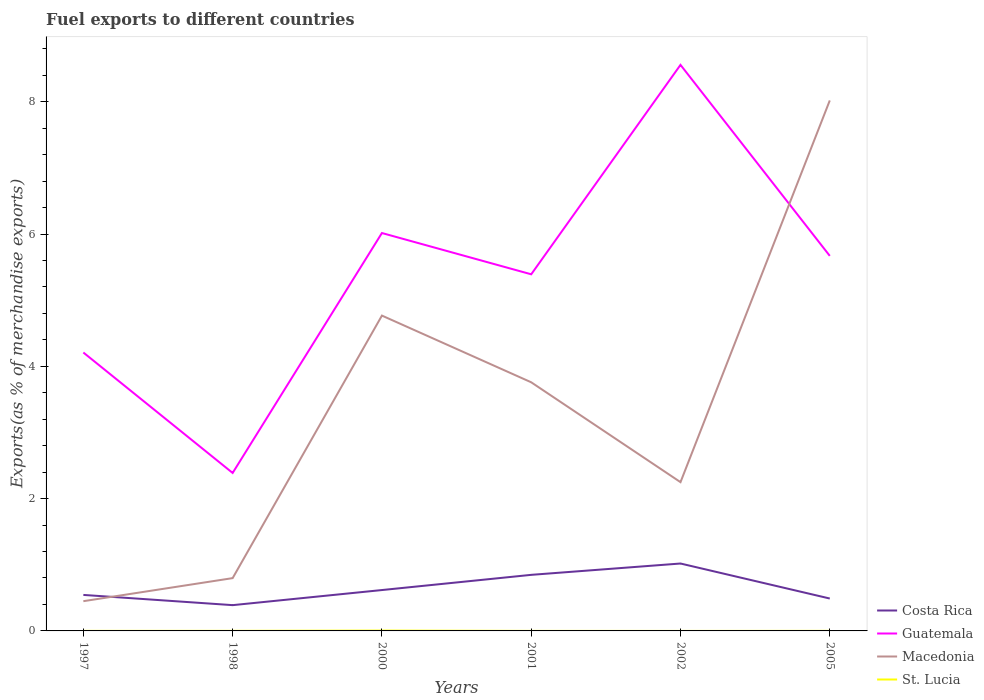Does the line corresponding to Costa Rica intersect with the line corresponding to Macedonia?
Give a very brief answer. Yes. Across all years, what is the maximum percentage of exports to different countries in Costa Rica?
Make the answer very short. 0.39. In which year was the percentage of exports to different countries in Macedonia maximum?
Your answer should be compact. 1997. What is the total percentage of exports to different countries in Guatemala in the graph?
Provide a succinct answer. -1.18. What is the difference between the highest and the second highest percentage of exports to different countries in Guatemala?
Ensure brevity in your answer.  6.17. Are the values on the major ticks of Y-axis written in scientific E-notation?
Ensure brevity in your answer.  No. Does the graph contain any zero values?
Your response must be concise. No. What is the title of the graph?
Your answer should be very brief. Fuel exports to different countries. Does "Indonesia" appear as one of the legend labels in the graph?
Give a very brief answer. No. What is the label or title of the X-axis?
Give a very brief answer. Years. What is the label or title of the Y-axis?
Your answer should be compact. Exports(as % of merchandise exports). What is the Exports(as % of merchandise exports) in Costa Rica in 1997?
Provide a succinct answer. 0.54. What is the Exports(as % of merchandise exports) in Guatemala in 1997?
Ensure brevity in your answer.  4.21. What is the Exports(as % of merchandise exports) of Macedonia in 1997?
Your answer should be compact. 0.45. What is the Exports(as % of merchandise exports) in St. Lucia in 1997?
Offer a very short reply. 0. What is the Exports(as % of merchandise exports) of Costa Rica in 1998?
Keep it short and to the point. 0.39. What is the Exports(as % of merchandise exports) in Guatemala in 1998?
Provide a short and direct response. 2.39. What is the Exports(as % of merchandise exports) in Macedonia in 1998?
Make the answer very short. 0.8. What is the Exports(as % of merchandise exports) of St. Lucia in 1998?
Offer a terse response. 0. What is the Exports(as % of merchandise exports) of Costa Rica in 2000?
Keep it short and to the point. 0.62. What is the Exports(as % of merchandise exports) in Guatemala in 2000?
Keep it short and to the point. 6.01. What is the Exports(as % of merchandise exports) in Macedonia in 2000?
Your answer should be compact. 4.77. What is the Exports(as % of merchandise exports) of St. Lucia in 2000?
Your response must be concise. 0.01. What is the Exports(as % of merchandise exports) of Costa Rica in 2001?
Your answer should be very brief. 0.85. What is the Exports(as % of merchandise exports) in Guatemala in 2001?
Provide a succinct answer. 5.39. What is the Exports(as % of merchandise exports) in Macedonia in 2001?
Your answer should be compact. 3.76. What is the Exports(as % of merchandise exports) of St. Lucia in 2001?
Your answer should be very brief. 0. What is the Exports(as % of merchandise exports) of Costa Rica in 2002?
Ensure brevity in your answer.  1.02. What is the Exports(as % of merchandise exports) of Guatemala in 2002?
Make the answer very short. 8.56. What is the Exports(as % of merchandise exports) of Macedonia in 2002?
Your answer should be very brief. 2.25. What is the Exports(as % of merchandise exports) of St. Lucia in 2002?
Your answer should be very brief. 4.657797227082891e-6. What is the Exports(as % of merchandise exports) of Costa Rica in 2005?
Make the answer very short. 0.49. What is the Exports(as % of merchandise exports) of Guatemala in 2005?
Your answer should be compact. 5.67. What is the Exports(as % of merchandise exports) in Macedonia in 2005?
Offer a terse response. 8.02. What is the Exports(as % of merchandise exports) of St. Lucia in 2005?
Offer a terse response. 0. Across all years, what is the maximum Exports(as % of merchandise exports) of Costa Rica?
Provide a short and direct response. 1.02. Across all years, what is the maximum Exports(as % of merchandise exports) of Guatemala?
Provide a short and direct response. 8.56. Across all years, what is the maximum Exports(as % of merchandise exports) in Macedonia?
Offer a very short reply. 8.02. Across all years, what is the maximum Exports(as % of merchandise exports) of St. Lucia?
Provide a short and direct response. 0.01. Across all years, what is the minimum Exports(as % of merchandise exports) in Costa Rica?
Your response must be concise. 0.39. Across all years, what is the minimum Exports(as % of merchandise exports) of Guatemala?
Provide a succinct answer. 2.39. Across all years, what is the minimum Exports(as % of merchandise exports) in Macedonia?
Give a very brief answer. 0.45. Across all years, what is the minimum Exports(as % of merchandise exports) of St. Lucia?
Your answer should be very brief. 4.657797227082891e-6. What is the total Exports(as % of merchandise exports) in Costa Rica in the graph?
Keep it short and to the point. 3.91. What is the total Exports(as % of merchandise exports) in Guatemala in the graph?
Your response must be concise. 32.23. What is the total Exports(as % of merchandise exports) in Macedonia in the graph?
Make the answer very short. 20.04. What is the total Exports(as % of merchandise exports) in St. Lucia in the graph?
Ensure brevity in your answer.  0.01. What is the difference between the Exports(as % of merchandise exports) in Costa Rica in 1997 and that in 1998?
Ensure brevity in your answer.  0.15. What is the difference between the Exports(as % of merchandise exports) of Guatemala in 1997 and that in 1998?
Give a very brief answer. 1.82. What is the difference between the Exports(as % of merchandise exports) in Macedonia in 1997 and that in 1998?
Make the answer very short. -0.35. What is the difference between the Exports(as % of merchandise exports) in St. Lucia in 1997 and that in 1998?
Offer a terse response. -0. What is the difference between the Exports(as % of merchandise exports) in Costa Rica in 1997 and that in 2000?
Your response must be concise. -0.07. What is the difference between the Exports(as % of merchandise exports) of Guatemala in 1997 and that in 2000?
Offer a terse response. -1.81. What is the difference between the Exports(as % of merchandise exports) in Macedonia in 1997 and that in 2000?
Your answer should be compact. -4.32. What is the difference between the Exports(as % of merchandise exports) in St. Lucia in 1997 and that in 2000?
Your answer should be very brief. -0. What is the difference between the Exports(as % of merchandise exports) in Costa Rica in 1997 and that in 2001?
Your response must be concise. -0.3. What is the difference between the Exports(as % of merchandise exports) in Guatemala in 1997 and that in 2001?
Give a very brief answer. -1.18. What is the difference between the Exports(as % of merchandise exports) of Macedonia in 1997 and that in 2001?
Your response must be concise. -3.31. What is the difference between the Exports(as % of merchandise exports) in Costa Rica in 1997 and that in 2002?
Offer a very short reply. -0.47. What is the difference between the Exports(as % of merchandise exports) of Guatemala in 1997 and that in 2002?
Give a very brief answer. -4.35. What is the difference between the Exports(as % of merchandise exports) of Macedonia in 1997 and that in 2002?
Provide a short and direct response. -1.8. What is the difference between the Exports(as % of merchandise exports) of St. Lucia in 1997 and that in 2002?
Your response must be concise. 0. What is the difference between the Exports(as % of merchandise exports) of Costa Rica in 1997 and that in 2005?
Provide a short and direct response. 0.05. What is the difference between the Exports(as % of merchandise exports) in Guatemala in 1997 and that in 2005?
Offer a very short reply. -1.46. What is the difference between the Exports(as % of merchandise exports) in Macedonia in 1997 and that in 2005?
Make the answer very short. -7.57. What is the difference between the Exports(as % of merchandise exports) of St. Lucia in 1997 and that in 2005?
Your answer should be compact. -0. What is the difference between the Exports(as % of merchandise exports) in Costa Rica in 1998 and that in 2000?
Your response must be concise. -0.23. What is the difference between the Exports(as % of merchandise exports) in Guatemala in 1998 and that in 2000?
Ensure brevity in your answer.  -3.63. What is the difference between the Exports(as % of merchandise exports) in Macedonia in 1998 and that in 2000?
Make the answer very short. -3.97. What is the difference between the Exports(as % of merchandise exports) in St. Lucia in 1998 and that in 2000?
Ensure brevity in your answer.  -0. What is the difference between the Exports(as % of merchandise exports) in Costa Rica in 1998 and that in 2001?
Give a very brief answer. -0.46. What is the difference between the Exports(as % of merchandise exports) in Guatemala in 1998 and that in 2001?
Provide a short and direct response. -3. What is the difference between the Exports(as % of merchandise exports) of Macedonia in 1998 and that in 2001?
Provide a short and direct response. -2.96. What is the difference between the Exports(as % of merchandise exports) of St. Lucia in 1998 and that in 2001?
Make the answer very short. 0. What is the difference between the Exports(as % of merchandise exports) in Costa Rica in 1998 and that in 2002?
Provide a succinct answer. -0.63. What is the difference between the Exports(as % of merchandise exports) of Guatemala in 1998 and that in 2002?
Keep it short and to the point. -6.17. What is the difference between the Exports(as % of merchandise exports) in Macedonia in 1998 and that in 2002?
Provide a short and direct response. -1.45. What is the difference between the Exports(as % of merchandise exports) in St. Lucia in 1998 and that in 2002?
Provide a succinct answer. 0. What is the difference between the Exports(as % of merchandise exports) of Costa Rica in 1998 and that in 2005?
Provide a succinct answer. -0.1. What is the difference between the Exports(as % of merchandise exports) of Guatemala in 1998 and that in 2005?
Your response must be concise. -3.28. What is the difference between the Exports(as % of merchandise exports) in Macedonia in 1998 and that in 2005?
Make the answer very short. -7.22. What is the difference between the Exports(as % of merchandise exports) of St. Lucia in 1998 and that in 2005?
Your response must be concise. 0. What is the difference between the Exports(as % of merchandise exports) in Costa Rica in 2000 and that in 2001?
Make the answer very short. -0.23. What is the difference between the Exports(as % of merchandise exports) of Guatemala in 2000 and that in 2001?
Your answer should be very brief. 0.62. What is the difference between the Exports(as % of merchandise exports) in Macedonia in 2000 and that in 2001?
Offer a terse response. 1.01. What is the difference between the Exports(as % of merchandise exports) of St. Lucia in 2000 and that in 2001?
Keep it short and to the point. 0. What is the difference between the Exports(as % of merchandise exports) of Costa Rica in 2000 and that in 2002?
Keep it short and to the point. -0.4. What is the difference between the Exports(as % of merchandise exports) in Guatemala in 2000 and that in 2002?
Your response must be concise. -2.54. What is the difference between the Exports(as % of merchandise exports) in Macedonia in 2000 and that in 2002?
Your answer should be compact. 2.52. What is the difference between the Exports(as % of merchandise exports) of St. Lucia in 2000 and that in 2002?
Provide a succinct answer. 0.01. What is the difference between the Exports(as % of merchandise exports) of Costa Rica in 2000 and that in 2005?
Keep it short and to the point. 0.13. What is the difference between the Exports(as % of merchandise exports) in Guatemala in 2000 and that in 2005?
Offer a very short reply. 0.35. What is the difference between the Exports(as % of merchandise exports) of Macedonia in 2000 and that in 2005?
Provide a short and direct response. -3.25. What is the difference between the Exports(as % of merchandise exports) of St. Lucia in 2000 and that in 2005?
Ensure brevity in your answer.  0. What is the difference between the Exports(as % of merchandise exports) in Costa Rica in 2001 and that in 2002?
Your response must be concise. -0.17. What is the difference between the Exports(as % of merchandise exports) in Guatemala in 2001 and that in 2002?
Offer a terse response. -3.17. What is the difference between the Exports(as % of merchandise exports) of Macedonia in 2001 and that in 2002?
Give a very brief answer. 1.51. What is the difference between the Exports(as % of merchandise exports) of St. Lucia in 2001 and that in 2002?
Your response must be concise. 0. What is the difference between the Exports(as % of merchandise exports) in Costa Rica in 2001 and that in 2005?
Offer a terse response. 0.36. What is the difference between the Exports(as % of merchandise exports) of Guatemala in 2001 and that in 2005?
Your response must be concise. -0.28. What is the difference between the Exports(as % of merchandise exports) in Macedonia in 2001 and that in 2005?
Offer a terse response. -4.26. What is the difference between the Exports(as % of merchandise exports) of St. Lucia in 2001 and that in 2005?
Give a very brief answer. -0. What is the difference between the Exports(as % of merchandise exports) of Costa Rica in 2002 and that in 2005?
Offer a terse response. 0.53. What is the difference between the Exports(as % of merchandise exports) of Guatemala in 2002 and that in 2005?
Your answer should be compact. 2.89. What is the difference between the Exports(as % of merchandise exports) in Macedonia in 2002 and that in 2005?
Keep it short and to the point. -5.77. What is the difference between the Exports(as % of merchandise exports) in St. Lucia in 2002 and that in 2005?
Ensure brevity in your answer.  -0. What is the difference between the Exports(as % of merchandise exports) of Costa Rica in 1997 and the Exports(as % of merchandise exports) of Guatemala in 1998?
Your answer should be very brief. -1.84. What is the difference between the Exports(as % of merchandise exports) of Costa Rica in 1997 and the Exports(as % of merchandise exports) of Macedonia in 1998?
Your response must be concise. -0.25. What is the difference between the Exports(as % of merchandise exports) in Costa Rica in 1997 and the Exports(as % of merchandise exports) in St. Lucia in 1998?
Provide a succinct answer. 0.54. What is the difference between the Exports(as % of merchandise exports) in Guatemala in 1997 and the Exports(as % of merchandise exports) in Macedonia in 1998?
Give a very brief answer. 3.41. What is the difference between the Exports(as % of merchandise exports) in Guatemala in 1997 and the Exports(as % of merchandise exports) in St. Lucia in 1998?
Provide a succinct answer. 4.21. What is the difference between the Exports(as % of merchandise exports) of Macedonia in 1997 and the Exports(as % of merchandise exports) of St. Lucia in 1998?
Your answer should be compact. 0.45. What is the difference between the Exports(as % of merchandise exports) of Costa Rica in 1997 and the Exports(as % of merchandise exports) of Guatemala in 2000?
Your answer should be compact. -5.47. What is the difference between the Exports(as % of merchandise exports) of Costa Rica in 1997 and the Exports(as % of merchandise exports) of Macedonia in 2000?
Provide a succinct answer. -4.22. What is the difference between the Exports(as % of merchandise exports) of Costa Rica in 1997 and the Exports(as % of merchandise exports) of St. Lucia in 2000?
Make the answer very short. 0.54. What is the difference between the Exports(as % of merchandise exports) in Guatemala in 1997 and the Exports(as % of merchandise exports) in Macedonia in 2000?
Provide a succinct answer. -0.56. What is the difference between the Exports(as % of merchandise exports) in Guatemala in 1997 and the Exports(as % of merchandise exports) in St. Lucia in 2000?
Give a very brief answer. 4.2. What is the difference between the Exports(as % of merchandise exports) of Macedonia in 1997 and the Exports(as % of merchandise exports) of St. Lucia in 2000?
Give a very brief answer. 0.44. What is the difference between the Exports(as % of merchandise exports) of Costa Rica in 1997 and the Exports(as % of merchandise exports) of Guatemala in 2001?
Provide a short and direct response. -4.85. What is the difference between the Exports(as % of merchandise exports) in Costa Rica in 1997 and the Exports(as % of merchandise exports) in Macedonia in 2001?
Make the answer very short. -3.21. What is the difference between the Exports(as % of merchandise exports) of Costa Rica in 1997 and the Exports(as % of merchandise exports) of St. Lucia in 2001?
Ensure brevity in your answer.  0.54. What is the difference between the Exports(as % of merchandise exports) of Guatemala in 1997 and the Exports(as % of merchandise exports) of Macedonia in 2001?
Offer a very short reply. 0.45. What is the difference between the Exports(as % of merchandise exports) of Guatemala in 1997 and the Exports(as % of merchandise exports) of St. Lucia in 2001?
Your answer should be compact. 4.21. What is the difference between the Exports(as % of merchandise exports) in Macedonia in 1997 and the Exports(as % of merchandise exports) in St. Lucia in 2001?
Offer a very short reply. 0.45. What is the difference between the Exports(as % of merchandise exports) in Costa Rica in 1997 and the Exports(as % of merchandise exports) in Guatemala in 2002?
Your answer should be very brief. -8.01. What is the difference between the Exports(as % of merchandise exports) in Costa Rica in 1997 and the Exports(as % of merchandise exports) in Macedonia in 2002?
Your answer should be very brief. -1.7. What is the difference between the Exports(as % of merchandise exports) of Costa Rica in 1997 and the Exports(as % of merchandise exports) of St. Lucia in 2002?
Provide a short and direct response. 0.54. What is the difference between the Exports(as % of merchandise exports) in Guatemala in 1997 and the Exports(as % of merchandise exports) in Macedonia in 2002?
Provide a short and direct response. 1.96. What is the difference between the Exports(as % of merchandise exports) of Guatemala in 1997 and the Exports(as % of merchandise exports) of St. Lucia in 2002?
Your answer should be compact. 4.21. What is the difference between the Exports(as % of merchandise exports) in Macedonia in 1997 and the Exports(as % of merchandise exports) in St. Lucia in 2002?
Provide a succinct answer. 0.45. What is the difference between the Exports(as % of merchandise exports) in Costa Rica in 1997 and the Exports(as % of merchandise exports) in Guatemala in 2005?
Offer a very short reply. -5.12. What is the difference between the Exports(as % of merchandise exports) of Costa Rica in 1997 and the Exports(as % of merchandise exports) of Macedonia in 2005?
Provide a succinct answer. -7.47. What is the difference between the Exports(as % of merchandise exports) in Costa Rica in 1997 and the Exports(as % of merchandise exports) in St. Lucia in 2005?
Provide a succinct answer. 0.54. What is the difference between the Exports(as % of merchandise exports) in Guatemala in 1997 and the Exports(as % of merchandise exports) in Macedonia in 2005?
Make the answer very short. -3.81. What is the difference between the Exports(as % of merchandise exports) in Guatemala in 1997 and the Exports(as % of merchandise exports) in St. Lucia in 2005?
Give a very brief answer. 4.21. What is the difference between the Exports(as % of merchandise exports) in Macedonia in 1997 and the Exports(as % of merchandise exports) in St. Lucia in 2005?
Keep it short and to the point. 0.45. What is the difference between the Exports(as % of merchandise exports) in Costa Rica in 1998 and the Exports(as % of merchandise exports) in Guatemala in 2000?
Your response must be concise. -5.63. What is the difference between the Exports(as % of merchandise exports) of Costa Rica in 1998 and the Exports(as % of merchandise exports) of Macedonia in 2000?
Your response must be concise. -4.38. What is the difference between the Exports(as % of merchandise exports) in Costa Rica in 1998 and the Exports(as % of merchandise exports) in St. Lucia in 2000?
Give a very brief answer. 0.38. What is the difference between the Exports(as % of merchandise exports) in Guatemala in 1998 and the Exports(as % of merchandise exports) in Macedonia in 2000?
Your answer should be compact. -2.38. What is the difference between the Exports(as % of merchandise exports) in Guatemala in 1998 and the Exports(as % of merchandise exports) in St. Lucia in 2000?
Keep it short and to the point. 2.38. What is the difference between the Exports(as % of merchandise exports) of Macedonia in 1998 and the Exports(as % of merchandise exports) of St. Lucia in 2000?
Provide a short and direct response. 0.79. What is the difference between the Exports(as % of merchandise exports) in Costa Rica in 1998 and the Exports(as % of merchandise exports) in Guatemala in 2001?
Give a very brief answer. -5. What is the difference between the Exports(as % of merchandise exports) of Costa Rica in 1998 and the Exports(as % of merchandise exports) of Macedonia in 2001?
Make the answer very short. -3.37. What is the difference between the Exports(as % of merchandise exports) of Costa Rica in 1998 and the Exports(as % of merchandise exports) of St. Lucia in 2001?
Your answer should be very brief. 0.39. What is the difference between the Exports(as % of merchandise exports) in Guatemala in 1998 and the Exports(as % of merchandise exports) in Macedonia in 2001?
Your answer should be very brief. -1.37. What is the difference between the Exports(as % of merchandise exports) in Guatemala in 1998 and the Exports(as % of merchandise exports) in St. Lucia in 2001?
Your response must be concise. 2.39. What is the difference between the Exports(as % of merchandise exports) in Macedonia in 1998 and the Exports(as % of merchandise exports) in St. Lucia in 2001?
Provide a short and direct response. 0.8. What is the difference between the Exports(as % of merchandise exports) of Costa Rica in 1998 and the Exports(as % of merchandise exports) of Guatemala in 2002?
Offer a terse response. -8.17. What is the difference between the Exports(as % of merchandise exports) in Costa Rica in 1998 and the Exports(as % of merchandise exports) in Macedonia in 2002?
Give a very brief answer. -1.86. What is the difference between the Exports(as % of merchandise exports) in Costa Rica in 1998 and the Exports(as % of merchandise exports) in St. Lucia in 2002?
Give a very brief answer. 0.39. What is the difference between the Exports(as % of merchandise exports) of Guatemala in 1998 and the Exports(as % of merchandise exports) of Macedonia in 2002?
Offer a terse response. 0.14. What is the difference between the Exports(as % of merchandise exports) of Guatemala in 1998 and the Exports(as % of merchandise exports) of St. Lucia in 2002?
Your answer should be very brief. 2.39. What is the difference between the Exports(as % of merchandise exports) in Macedonia in 1998 and the Exports(as % of merchandise exports) in St. Lucia in 2002?
Provide a succinct answer. 0.8. What is the difference between the Exports(as % of merchandise exports) of Costa Rica in 1998 and the Exports(as % of merchandise exports) of Guatemala in 2005?
Offer a terse response. -5.28. What is the difference between the Exports(as % of merchandise exports) in Costa Rica in 1998 and the Exports(as % of merchandise exports) in Macedonia in 2005?
Give a very brief answer. -7.63. What is the difference between the Exports(as % of merchandise exports) in Costa Rica in 1998 and the Exports(as % of merchandise exports) in St. Lucia in 2005?
Provide a short and direct response. 0.39. What is the difference between the Exports(as % of merchandise exports) of Guatemala in 1998 and the Exports(as % of merchandise exports) of Macedonia in 2005?
Ensure brevity in your answer.  -5.63. What is the difference between the Exports(as % of merchandise exports) in Guatemala in 1998 and the Exports(as % of merchandise exports) in St. Lucia in 2005?
Offer a very short reply. 2.39. What is the difference between the Exports(as % of merchandise exports) in Macedonia in 1998 and the Exports(as % of merchandise exports) in St. Lucia in 2005?
Your answer should be compact. 0.8. What is the difference between the Exports(as % of merchandise exports) in Costa Rica in 2000 and the Exports(as % of merchandise exports) in Guatemala in 2001?
Offer a very short reply. -4.77. What is the difference between the Exports(as % of merchandise exports) in Costa Rica in 2000 and the Exports(as % of merchandise exports) in Macedonia in 2001?
Your answer should be very brief. -3.14. What is the difference between the Exports(as % of merchandise exports) in Costa Rica in 2000 and the Exports(as % of merchandise exports) in St. Lucia in 2001?
Your response must be concise. 0.62. What is the difference between the Exports(as % of merchandise exports) of Guatemala in 2000 and the Exports(as % of merchandise exports) of Macedonia in 2001?
Make the answer very short. 2.26. What is the difference between the Exports(as % of merchandise exports) in Guatemala in 2000 and the Exports(as % of merchandise exports) in St. Lucia in 2001?
Provide a short and direct response. 6.01. What is the difference between the Exports(as % of merchandise exports) in Macedonia in 2000 and the Exports(as % of merchandise exports) in St. Lucia in 2001?
Offer a very short reply. 4.77. What is the difference between the Exports(as % of merchandise exports) in Costa Rica in 2000 and the Exports(as % of merchandise exports) in Guatemala in 2002?
Your answer should be compact. -7.94. What is the difference between the Exports(as % of merchandise exports) of Costa Rica in 2000 and the Exports(as % of merchandise exports) of Macedonia in 2002?
Provide a succinct answer. -1.63. What is the difference between the Exports(as % of merchandise exports) in Costa Rica in 2000 and the Exports(as % of merchandise exports) in St. Lucia in 2002?
Offer a very short reply. 0.62. What is the difference between the Exports(as % of merchandise exports) of Guatemala in 2000 and the Exports(as % of merchandise exports) of Macedonia in 2002?
Offer a terse response. 3.77. What is the difference between the Exports(as % of merchandise exports) in Guatemala in 2000 and the Exports(as % of merchandise exports) in St. Lucia in 2002?
Your answer should be compact. 6.01. What is the difference between the Exports(as % of merchandise exports) of Macedonia in 2000 and the Exports(as % of merchandise exports) of St. Lucia in 2002?
Offer a very short reply. 4.77. What is the difference between the Exports(as % of merchandise exports) of Costa Rica in 2000 and the Exports(as % of merchandise exports) of Guatemala in 2005?
Offer a very short reply. -5.05. What is the difference between the Exports(as % of merchandise exports) in Costa Rica in 2000 and the Exports(as % of merchandise exports) in Macedonia in 2005?
Give a very brief answer. -7.4. What is the difference between the Exports(as % of merchandise exports) in Costa Rica in 2000 and the Exports(as % of merchandise exports) in St. Lucia in 2005?
Ensure brevity in your answer.  0.62. What is the difference between the Exports(as % of merchandise exports) of Guatemala in 2000 and the Exports(as % of merchandise exports) of Macedonia in 2005?
Provide a short and direct response. -2. What is the difference between the Exports(as % of merchandise exports) in Guatemala in 2000 and the Exports(as % of merchandise exports) in St. Lucia in 2005?
Your response must be concise. 6.01. What is the difference between the Exports(as % of merchandise exports) of Macedonia in 2000 and the Exports(as % of merchandise exports) of St. Lucia in 2005?
Provide a succinct answer. 4.77. What is the difference between the Exports(as % of merchandise exports) in Costa Rica in 2001 and the Exports(as % of merchandise exports) in Guatemala in 2002?
Your response must be concise. -7.71. What is the difference between the Exports(as % of merchandise exports) of Costa Rica in 2001 and the Exports(as % of merchandise exports) of Macedonia in 2002?
Offer a terse response. -1.4. What is the difference between the Exports(as % of merchandise exports) of Costa Rica in 2001 and the Exports(as % of merchandise exports) of St. Lucia in 2002?
Your answer should be very brief. 0.85. What is the difference between the Exports(as % of merchandise exports) of Guatemala in 2001 and the Exports(as % of merchandise exports) of Macedonia in 2002?
Your answer should be compact. 3.14. What is the difference between the Exports(as % of merchandise exports) of Guatemala in 2001 and the Exports(as % of merchandise exports) of St. Lucia in 2002?
Give a very brief answer. 5.39. What is the difference between the Exports(as % of merchandise exports) in Macedonia in 2001 and the Exports(as % of merchandise exports) in St. Lucia in 2002?
Provide a succinct answer. 3.76. What is the difference between the Exports(as % of merchandise exports) in Costa Rica in 2001 and the Exports(as % of merchandise exports) in Guatemala in 2005?
Offer a terse response. -4.82. What is the difference between the Exports(as % of merchandise exports) of Costa Rica in 2001 and the Exports(as % of merchandise exports) of Macedonia in 2005?
Keep it short and to the point. -7.17. What is the difference between the Exports(as % of merchandise exports) of Costa Rica in 2001 and the Exports(as % of merchandise exports) of St. Lucia in 2005?
Provide a short and direct response. 0.85. What is the difference between the Exports(as % of merchandise exports) in Guatemala in 2001 and the Exports(as % of merchandise exports) in Macedonia in 2005?
Your answer should be compact. -2.63. What is the difference between the Exports(as % of merchandise exports) of Guatemala in 2001 and the Exports(as % of merchandise exports) of St. Lucia in 2005?
Your answer should be compact. 5.39. What is the difference between the Exports(as % of merchandise exports) in Macedonia in 2001 and the Exports(as % of merchandise exports) in St. Lucia in 2005?
Offer a terse response. 3.76. What is the difference between the Exports(as % of merchandise exports) of Costa Rica in 2002 and the Exports(as % of merchandise exports) of Guatemala in 2005?
Provide a succinct answer. -4.65. What is the difference between the Exports(as % of merchandise exports) of Costa Rica in 2002 and the Exports(as % of merchandise exports) of Macedonia in 2005?
Provide a succinct answer. -7. What is the difference between the Exports(as % of merchandise exports) in Costa Rica in 2002 and the Exports(as % of merchandise exports) in St. Lucia in 2005?
Offer a very short reply. 1.02. What is the difference between the Exports(as % of merchandise exports) in Guatemala in 2002 and the Exports(as % of merchandise exports) in Macedonia in 2005?
Ensure brevity in your answer.  0.54. What is the difference between the Exports(as % of merchandise exports) in Guatemala in 2002 and the Exports(as % of merchandise exports) in St. Lucia in 2005?
Offer a very short reply. 8.56. What is the difference between the Exports(as % of merchandise exports) of Macedonia in 2002 and the Exports(as % of merchandise exports) of St. Lucia in 2005?
Your answer should be compact. 2.25. What is the average Exports(as % of merchandise exports) of Costa Rica per year?
Make the answer very short. 0.65. What is the average Exports(as % of merchandise exports) of Guatemala per year?
Ensure brevity in your answer.  5.37. What is the average Exports(as % of merchandise exports) of Macedonia per year?
Provide a succinct answer. 3.34. What is the average Exports(as % of merchandise exports) of St. Lucia per year?
Keep it short and to the point. 0. In the year 1997, what is the difference between the Exports(as % of merchandise exports) in Costa Rica and Exports(as % of merchandise exports) in Guatemala?
Your response must be concise. -3.66. In the year 1997, what is the difference between the Exports(as % of merchandise exports) in Costa Rica and Exports(as % of merchandise exports) in Macedonia?
Your response must be concise. 0.09. In the year 1997, what is the difference between the Exports(as % of merchandise exports) in Costa Rica and Exports(as % of merchandise exports) in St. Lucia?
Provide a short and direct response. 0.54. In the year 1997, what is the difference between the Exports(as % of merchandise exports) of Guatemala and Exports(as % of merchandise exports) of Macedonia?
Keep it short and to the point. 3.76. In the year 1997, what is the difference between the Exports(as % of merchandise exports) of Guatemala and Exports(as % of merchandise exports) of St. Lucia?
Offer a terse response. 4.21. In the year 1997, what is the difference between the Exports(as % of merchandise exports) of Macedonia and Exports(as % of merchandise exports) of St. Lucia?
Your answer should be compact. 0.45. In the year 1998, what is the difference between the Exports(as % of merchandise exports) in Costa Rica and Exports(as % of merchandise exports) in Guatemala?
Your answer should be compact. -2. In the year 1998, what is the difference between the Exports(as % of merchandise exports) of Costa Rica and Exports(as % of merchandise exports) of Macedonia?
Ensure brevity in your answer.  -0.41. In the year 1998, what is the difference between the Exports(as % of merchandise exports) of Costa Rica and Exports(as % of merchandise exports) of St. Lucia?
Provide a succinct answer. 0.39. In the year 1998, what is the difference between the Exports(as % of merchandise exports) of Guatemala and Exports(as % of merchandise exports) of Macedonia?
Provide a short and direct response. 1.59. In the year 1998, what is the difference between the Exports(as % of merchandise exports) of Guatemala and Exports(as % of merchandise exports) of St. Lucia?
Your answer should be compact. 2.39. In the year 1998, what is the difference between the Exports(as % of merchandise exports) of Macedonia and Exports(as % of merchandise exports) of St. Lucia?
Keep it short and to the point. 0.8. In the year 2000, what is the difference between the Exports(as % of merchandise exports) of Costa Rica and Exports(as % of merchandise exports) of Guatemala?
Keep it short and to the point. -5.4. In the year 2000, what is the difference between the Exports(as % of merchandise exports) of Costa Rica and Exports(as % of merchandise exports) of Macedonia?
Give a very brief answer. -4.15. In the year 2000, what is the difference between the Exports(as % of merchandise exports) of Costa Rica and Exports(as % of merchandise exports) of St. Lucia?
Offer a terse response. 0.61. In the year 2000, what is the difference between the Exports(as % of merchandise exports) in Guatemala and Exports(as % of merchandise exports) in Macedonia?
Your response must be concise. 1.25. In the year 2000, what is the difference between the Exports(as % of merchandise exports) in Guatemala and Exports(as % of merchandise exports) in St. Lucia?
Offer a very short reply. 6.01. In the year 2000, what is the difference between the Exports(as % of merchandise exports) of Macedonia and Exports(as % of merchandise exports) of St. Lucia?
Your response must be concise. 4.76. In the year 2001, what is the difference between the Exports(as % of merchandise exports) in Costa Rica and Exports(as % of merchandise exports) in Guatemala?
Your answer should be very brief. -4.54. In the year 2001, what is the difference between the Exports(as % of merchandise exports) of Costa Rica and Exports(as % of merchandise exports) of Macedonia?
Provide a short and direct response. -2.91. In the year 2001, what is the difference between the Exports(as % of merchandise exports) of Costa Rica and Exports(as % of merchandise exports) of St. Lucia?
Make the answer very short. 0.85. In the year 2001, what is the difference between the Exports(as % of merchandise exports) in Guatemala and Exports(as % of merchandise exports) in Macedonia?
Offer a very short reply. 1.63. In the year 2001, what is the difference between the Exports(as % of merchandise exports) of Guatemala and Exports(as % of merchandise exports) of St. Lucia?
Offer a terse response. 5.39. In the year 2001, what is the difference between the Exports(as % of merchandise exports) of Macedonia and Exports(as % of merchandise exports) of St. Lucia?
Your answer should be very brief. 3.76. In the year 2002, what is the difference between the Exports(as % of merchandise exports) in Costa Rica and Exports(as % of merchandise exports) in Guatemala?
Offer a very short reply. -7.54. In the year 2002, what is the difference between the Exports(as % of merchandise exports) in Costa Rica and Exports(as % of merchandise exports) in Macedonia?
Offer a very short reply. -1.23. In the year 2002, what is the difference between the Exports(as % of merchandise exports) in Costa Rica and Exports(as % of merchandise exports) in St. Lucia?
Provide a short and direct response. 1.02. In the year 2002, what is the difference between the Exports(as % of merchandise exports) in Guatemala and Exports(as % of merchandise exports) in Macedonia?
Your answer should be compact. 6.31. In the year 2002, what is the difference between the Exports(as % of merchandise exports) of Guatemala and Exports(as % of merchandise exports) of St. Lucia?
Offer a very short reply. 8.56. In the year 2002, what is the difference between the Exports(as % of merchandise exports) of Macedonia and Exports(as % of merchandise exports) of St. Lucia?
Ensure brevity in your answer.  2.25. In the year 2005, what is the difference between the Exports(as % of merchandise exports) in Costa Rica and Exports(as % of merchandise exports) in Guatemala?
Keep it short and to the point. -5.18. In the year 2005, what is the difference between the Exports(as % of merchandise exports) in Costa Rica and Exports(as % of merchandise exports) in Macedonia?
Offer a terse response. -7.53. In the year 2005, what is the difference between the Exports(as % of merchandise exports) of Costa Rica and Exports(as % of merchandise exports) of St. Lucia?
Your answer should be very brief. 0.49. In the year 2005, what is the difference between the Exports(as % of merchandise exports) in Guatemala and Exports(as % of merchandise exports) in Macedonia?
Your answer should be very brief. -2.35. In the year 2005, what is the difference between the Exports(as % of merchandise exports) in Guatemala and Exports(as % of merchandise exports) in St. Lucia?
Provide a succinct answer. 5.67. In the year 2005, what is the difference between the Exports(as % of merchandise exports) in Macedonia and Exports(as % of merchandise exports) in St. Lucia?
Make the answer very short. 8.02. What is the ratio of the Exports(as % of merchandise exports) of Costa Rica in 1997 to that in 1998?
Ensure brevity in your answer.  1.4. What is the ratio of the Exports(as % of merchandise exports) of Guatemala in 1997 to that in 1998?
Give a very brief answer. 1.76. What is the ratio of the Exports(as % of merchandise exports) of Macedonia in 1997 to that in 1998?
Your answer should be very brief. 0.56. What is the ratio of the Exports(as % of merchandise exports) of St. Lucia in 1997 to that in 1998?
Offer a terse response. 0.71. What is the ratio of the Exports(as % of merchandise exports) in Costa Rica in 1997 to that in 2000?
Your answer should be compact. 0.88. What is the ratio of the Exports(as % of merchandise exports) of Guatemala in 1997 to that in 2000?
Offer a very short reply. 0.7. What is the ratio of the Exports(as % of merchandise exports) of Macedonia in 1997 to that in 2000?
Offer a very short reply. 0.09. What is the ratio of the Exports(as % of merchandise exports) in St. Lucia in 1997 to that in 2000?
Your answer should be very brief. 0.15. What is the ratio of the Exports(as % of merchandise exports) in Costa Rica in 1997 to that in 2001?
Offer a very short reply. 0.64. What is the ratio of the Exports(as % of merchandise exports) of Guatemala in 1997 to that in 2001?
Offer a very short reply. 0.78. What is the ratio of the Exports(as % of merchandise exports) in Macedonia in 1997 to that in 2001?
Provide a succinct answer. 0.12. What is the ratio of the Exports(as % of merchandise exports) in St. Lucia in 1997 to that in 2001?
Offer a terse response. 1.41. What is the ratio of the Exports(as % of merchandise exports) of Costa Rica in 1997 to that in 2002?
Ensure brevity in your answer.  0.53. What is the ratio of the Exports(as % of merchandise exports) in Guatemala in 1997 to that in 2002?
Provide a short and direct response. 0.49. What is the ratio of the Exports(as % of merchandise exports) of Macedonia in 1997 to that in 2002?
Your response must be concise. 0.2. What is the ratio of the Exports(as % of merchandise exports) of St. Lucia in 1997 to that in 2002?
Offer a terse response. 175.12. What is the ratio of the Exports(as % of merchandise exports) in Costa Rica in 1997 to that in 2005?
Offer a very short reply. 1.11. What is the ratio of the Exports(as % of merchandise exports) in Guatemala in 1997 to that in 2005?
Offer a very short reply. 0.74. What is the ratio of the Exports(as % of merchandise exports) of Macedonia in 1997 to that in 2005?
Your answer should be very brief. 0.06. What is the ratio of the Exports(as % of merchandise exports) of St. Lucia in 1997 to that in 2005?
Offer a very short reply. 0.81. What is the ratio of the Exports(as % of merchandise exports) of Costa Rica in 1998 to that in 2000?
Keep it short and to the point. 0.63. What is the ratio of the Exports(as % of merchandise exports) of Guatemala in 1998 to that in 2000?
Provide a succinct answer. 0.4. What is the ratio of the Exports(as % of merchandise exports) in Macedonia in 1998 to that in 2000?
Offer a terse response. 0.17. What is the ratio of the Exports(as % of merchandise exports) of St. Lucia in 1998 to that in 2000?
Provide a short and direct response. 0.22. What is the ratio of the Exports(as % of merchandise exports) in Costa Rica in 1998 to that in 2001?
Provide a succinct answer. 0.46. What is the ratio of the Exports(as % of merchandise exports) of Guatemala in 1998 to that in 2001?
Offer a terse response. 0.44. What is the ratio of the Exports(as % of merchandise exports) in Macedonia in 1998 to that in 2001?
Provide a short and direct response. 0.21. What is the ratio of the Exports(as % of merchandise exports) in St. Lucia in 1998 to that in 2001?
Provide a succinct answer. 1.99. What is the ratio of the Exports(as % of merchandise exports) of Costa Rica in 1998 to that in 2002?
Offer a very short reply. 0.38. What is the ratio of the Exports(as % of merchandise exports) in Guatemala in 1998 to that in 2002?
Your answer should be very brief. 0.28. What is the ratio of the Exports(as % of merchandise exports) in Macedonia in 1998 to that in 2002?
Give a very brief answer. 0.35. What is the ratio of the Exports(as % of merchandise exports) of St. Lucia in 1998 to that in 2002?
Provide a succinct answer. 246.42. What is the ratio of the Exports(as % of merchandise exports) in Costa Rica in 1998 to that in 2005?
Provide a succinct answer. 0.8. What is the ratio of the Exports(as % of merchandise exports) in Guatemala in 1998 to that in 2005?
Offer a very short reply. 0.42. What is the ratio of the Exports(as % of merchandise exports) of Macedonia in 1998 to that in 2005?
Your answer should be compact. 0.1. What is the ratio of the Exports(as % of merchandise exports) of St. Lucia in 1998 to that in 2005?
Keep it short and to the point. 1.14. What is the ratio of the Exports(as % of merchandise exports) of Costa Rica in 2000 to that in 2001?
Your answer should be very brief. 0.73. What is the ratio of the Exports(as % of merchandise exports) of Guatemala in 2000 to that in 2001?
Your response must be concise. 1.12. What is the ratio of the Exports(as % of merchandise exports) of Macedonia in 2000 to that in 2001?
Give a very brief answer. 1.27. What is the ratio of the Exports(as % of merchandise exports) of St. Lucia in 2000 to that in 2001?
Offer a very short reply. 9.2. What is the ratio of the Exports(as % of merchandise exports) of Costa Rica in 2000 to that in 2002?
Offer a terse response. 0.61. What is the ratio of the Exports(as % of merchandise exports) in Guatemala in 2000 to that in 2002?
Your response must be concise. 0.7. What is the ratio of the Exports(as % of merchandise exports) of Macedonia in 2000 to that in 2002?
Give a very brief answer. 2.12. What is the ratio of the Exports(as % of merchandise exports) of St. Lucia in 2000 to that in 2002?
Ensure brevity in your answer.  1138.98. What is the ratio of the Exports(as % of merchandise exports) of Costa Rica in 2000 to that in 2005?
Your response must be concise. 1.26. What is the ratio of the Exports(as % of merchandise exports) in Guatemala in 2000 to that in 2005?
Keep it short and to the point. 1.06. What is the ratio of the Exports(as % of merchandise exports) in Macedonia in 2000 to that in 2005?
Your answer should be very brief. 0.59. What is the ratio of the Exports(as % of merchandise exports) of St. Lucia in 2000 to that in 2005?
Your answer should be compact. 5.28. What is the ratio of the Exports(as % of merchandise exports) of Costa Rica in 2001 to that in 2002?
Provide a succinct answer. 0.83. What is the ratio of the Exports(as % of merchandise exports) in Guatemala in 2001 to that in 2002?
Make the answer very short. 0.63. What is the ratio of the Exports(as % of merchandise exports) of Macedonia in 2001 to that in 2002?
Your answer should be very brief. 1.67. What is the ratio of the Exports(as % of merchandise exports) of St. Lucia in 2001 to that in 2002?
Provide a succinct answer. 123.86. What is the ratio of the Exports(as % of merchandise exports) of Costa Rica in 2001 to that in 2005?
Ensure brevity in your answer.  1.73. What is the ratio of the Exports(as % of merchandise exports) in Guatemala in 2001 to that in 2005?
Give a very brief answer. 0.95. What is the ratio of the Exports(as % of merchandise exports) of Macedonia in 2001 to that in 2005?
Make the answer very short. 0.47. What is the ratio of the Exports(as % of merchandise exports) in St. Lucia in 2001 to that in 2005?
Give a very brief answer. 0.57. What is the ratio of the Exports(as % of merchandise exports) of Costa Rica in 2002 to that in 2005?
Your response must be concise. 2.08. What is the ratio of the Exports(as % of merchandise exports) of Guatemala in 2002 to that in 2005?
Your answer should be very brief. 1.51. What is the ratio of the Exports(as % of merchandise exports) of Macedonia in 2002 to that in 2005?
Your answer should be very brief. 0.28. What is the ratio of the Exports(as % of merchandise exports) in St. Lucia in 2002 to that in 2005?
Offer a very short reply. 0. What is the difference between the highest and the second highest Exports(as % of merchandise exports) of Costa Rica?
Offer a very short reply. 0.17. What is the difference between the highest and the second highest Exports(as % of merchandise exports) of Guatemala?
Offer a very short reply. 2.54. What is the difference between the highest and the second highest Exports(as % of merchandise exports) in Macedonia?
Your response must be concise. 3.25. What is the difference between the highest and the second highest Exports(as % of merchandise exports) of St. Lucia?
Provide a short and direct response. 0. What is the difference between the highest and the lowest Exports(as % of merchandise exports) in Costa Rica?
Your answer should be very brief. 0.63. What is the difference between the highest and the lowest Exports(as % of merchandise exports) of Guatemala?
Offer a very short reply. 6.17. What is the difference between the highest and the lowest Exports(as % of merchandise exports) of Macedonia?
Your answer should be compact. 7.57. What is the difference between the highest and the lowest Exports(as % of merchandise exports) of St. Lucia?
Your answer should be compact. 0.01. 